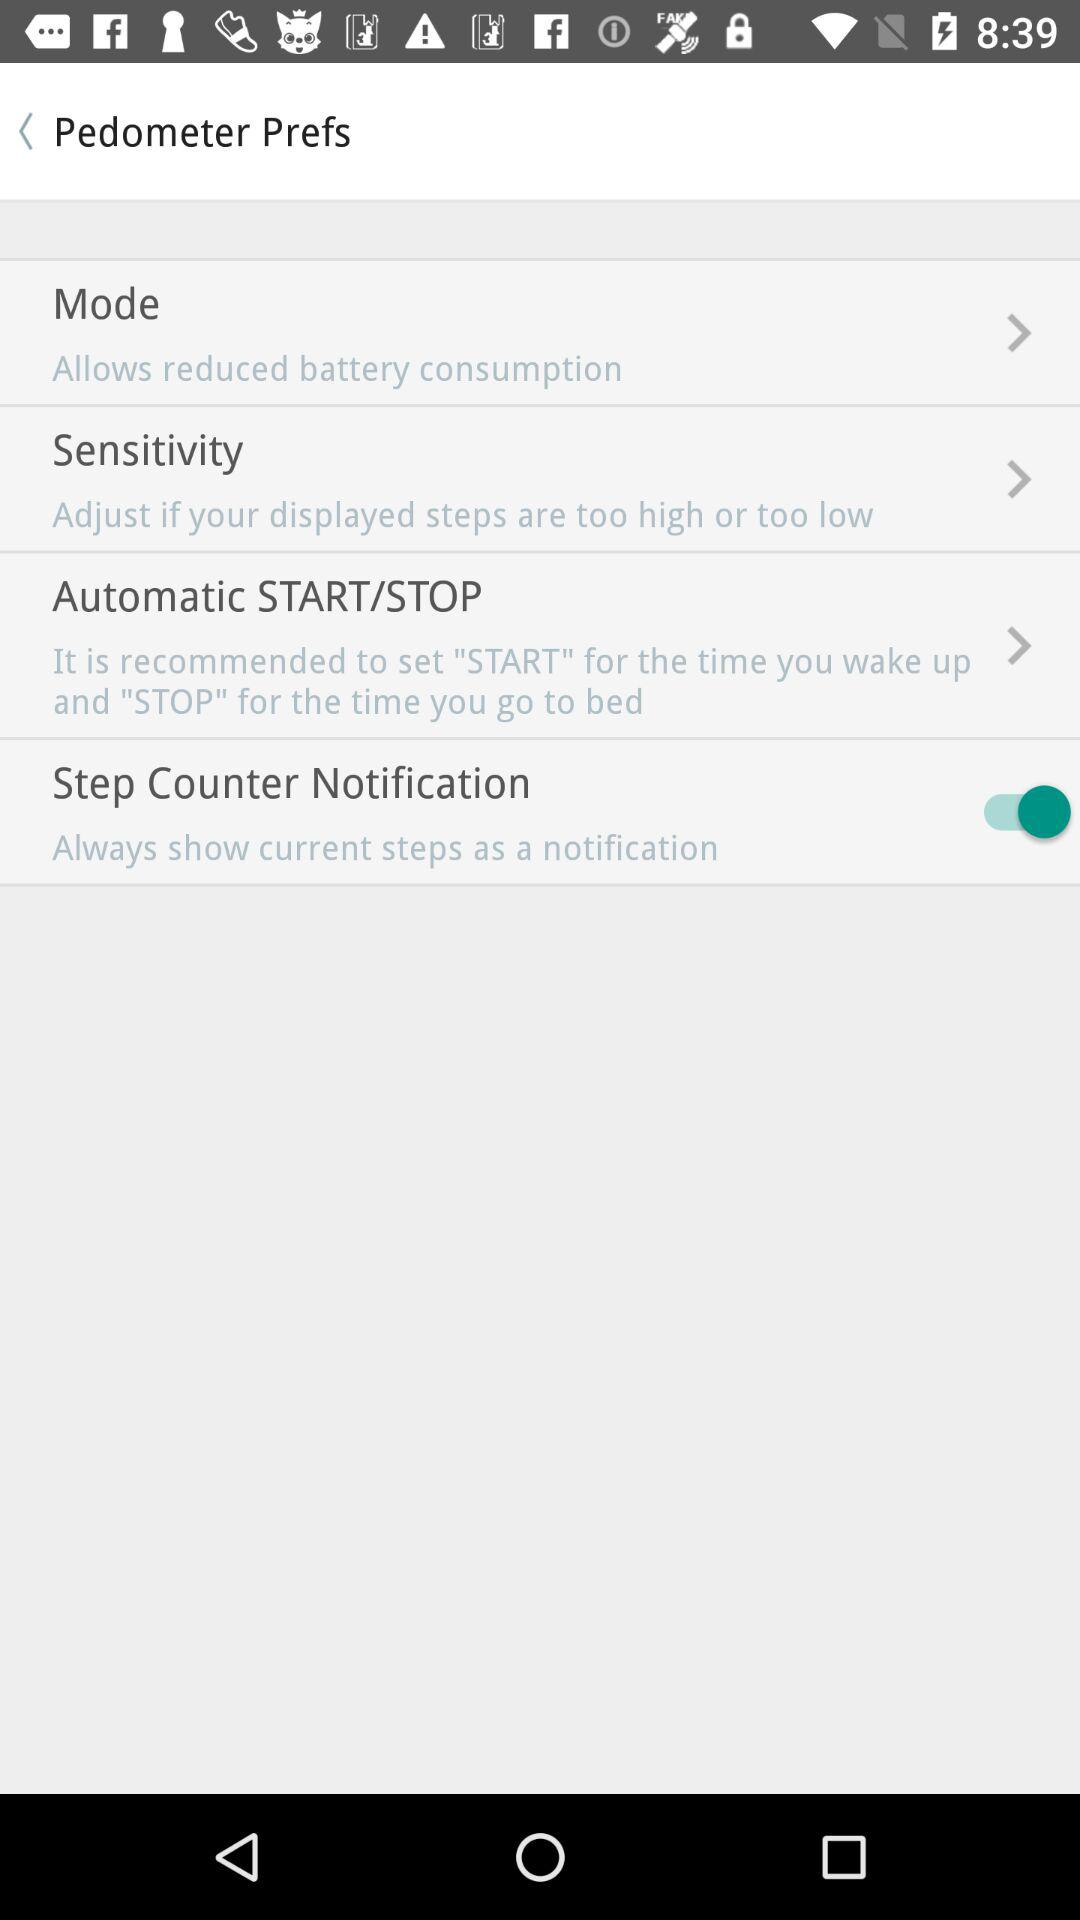What is the status of "Step Counter Notification"? The status is "on". 